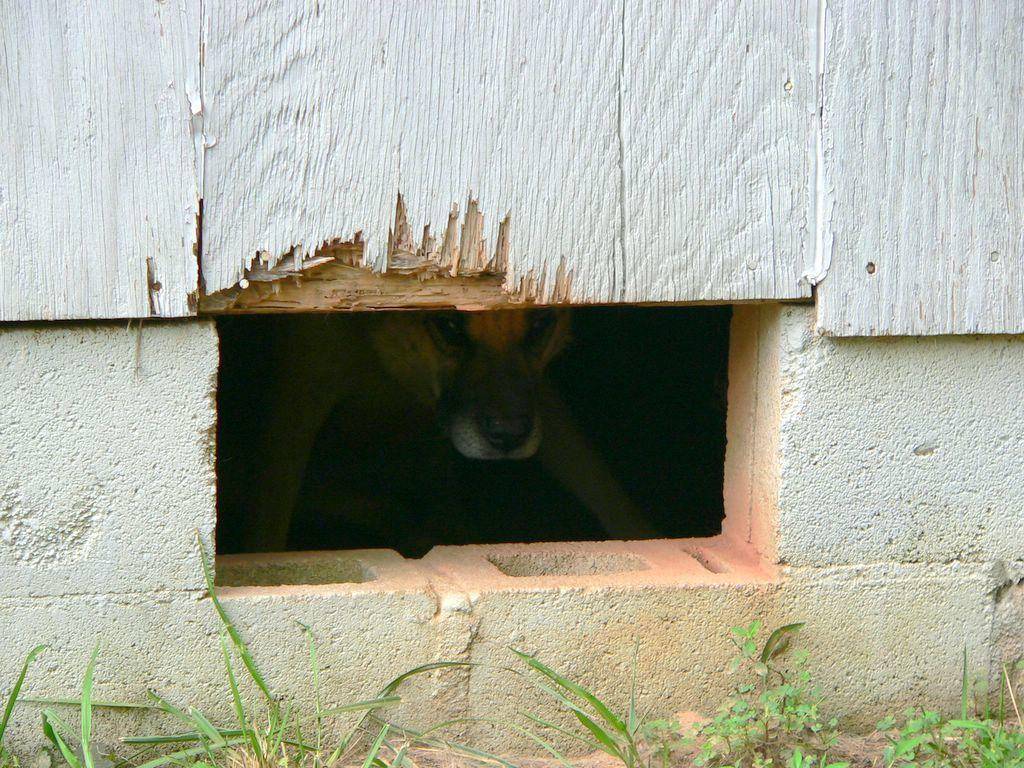What type of weather condition is visible in the image? There is fog in the image. How is the fog visible in the image? The fog is visible through an opening. What type of vegetation is present at the bottom of the image? There is grass at the bottom of the image. What type of material is present at the bottom of the image? Cement blocks are present at the bottom of the image. What type of wall is visible at the top of the image? There is a wooden wall at the top of the image. What color is the wooden wall? The wooden wall is white in color. Can you see the monkey's hair in the image? There is no monkey or mention of hair in the image. 